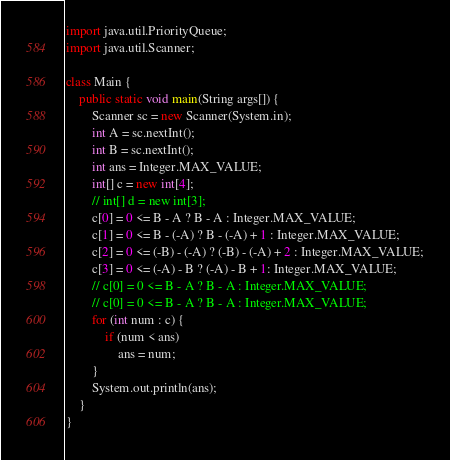Convert code to text. <code><loc_0><loc_0><loc_500><loc_500><_Java_>import java.util.PriorityQueue;
import java.util.Scanner;

class Main {
    public static void main(String args[]) {
        Scanner sc = new Scanner(System.in);
        int A = sc.nextInt();
        int B = sc.nextInt();
        int ans = Integer.MAX_VALUE;
        int[] c = new int[4];
        // int[] d = new int[3];
        c[0] = 0 <= B - A ? B - A : Integer.MAX_VALUE;
        c[1] = 0 <= B - (-A) ? B - (-A) + 1 : Integer.MAX_VALUE;
        c[2] = 0 <= (-B) - (-A) ? (-B) - (-A) + 2 : Integer.MAX_VALUE;
        c[3] = 0 <= (-A) - B ? (-A) - B + 1: Integer.MAX_VALUE;
        // c[0] = 0 <= B - A ? B - A : Integer.MAX_VALUE;
        // c[0] = 0 <= B - A ? B - A : Integer.MAX_VALUE;
        for (int num : c) {
            if (num < ans)
                ans = num;
        }
        System.out.println(ans);
    }
}</code> 